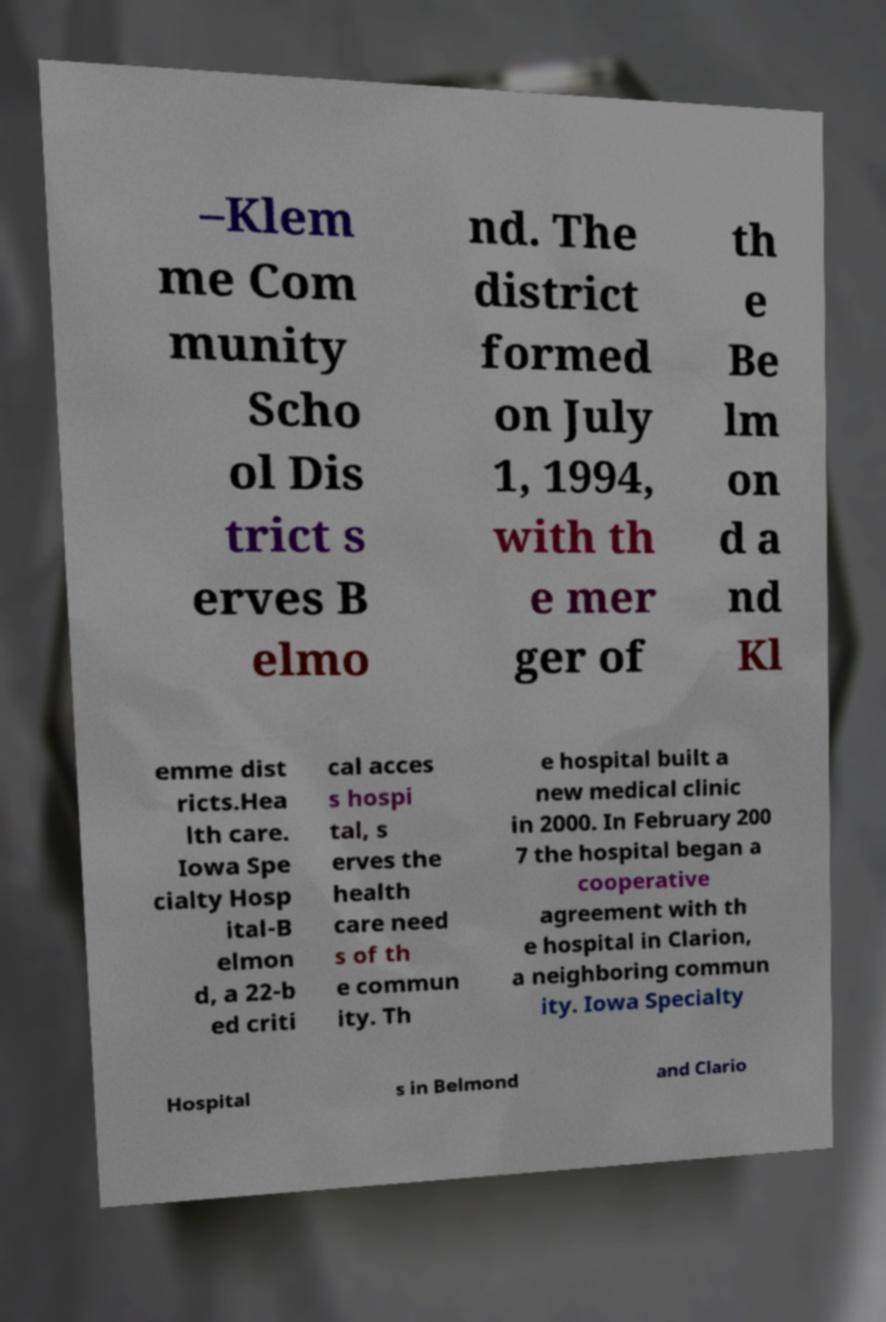Please identify and transcribe the text found in this image. –Klem me Com munity Scho ol Dis trict s erves B elmo nd. The district formed on July 1, 1994, with th e mer ger of th e Be lm on d a nd Kl emme dist ricts.Hea lth care. Iowa Spe cialty Hosp ital-B elmon d, a 22-b ed criti cal acces s hospi tal, s erves the health care need s of th e commun ity. Th e hospital built a new medical clinic in 2000. In February 200 7 the hospital began a cooperative agreement with th e hospital in Clarion, a neighboring commun ity. Iowa Specialty Hospital s in Belmond and Clario 